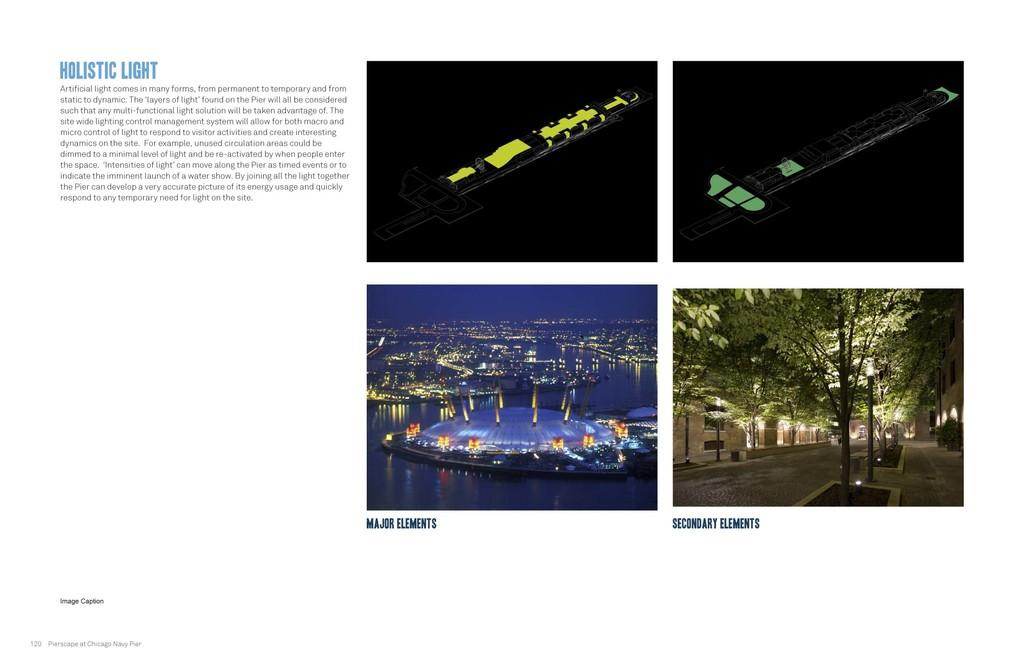What type of pictures are on the right side of the image? There are collage pictures on the right side of the image. What subjects are included in the collage pictures? The collage pictures include images of trees, city, and drawings. What can be found on the left side of the image? There is text on the left side of the image. What type of music can be heard playing in the background of the image? There is no music or sound present in the image, as it is a still image. Is there any evidence of a war in the collage pictures? There is no mention or depiction of war in the collage pictures, which include images of trees, city, and drawings. 